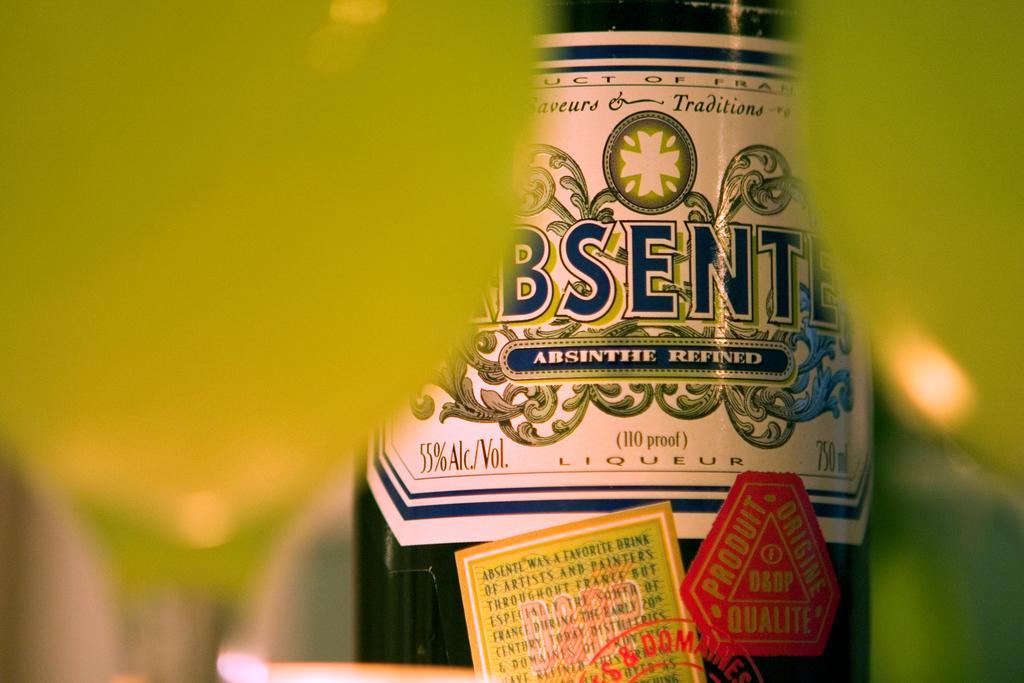<image>
Create a compact narrative representing the image presented. A bottle of Absinthe Refined 110 proof Liqueur with a green and white label. 